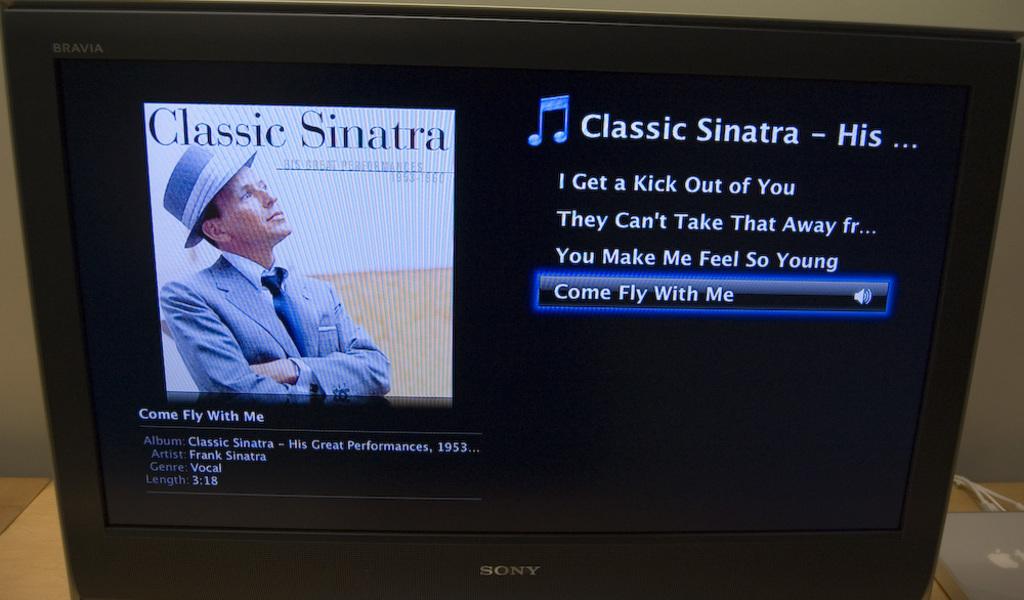What sinatra song is that?
Provide a succinct answer. Come fly with me. How long is the song?
Your response must be concise. 3:18. 